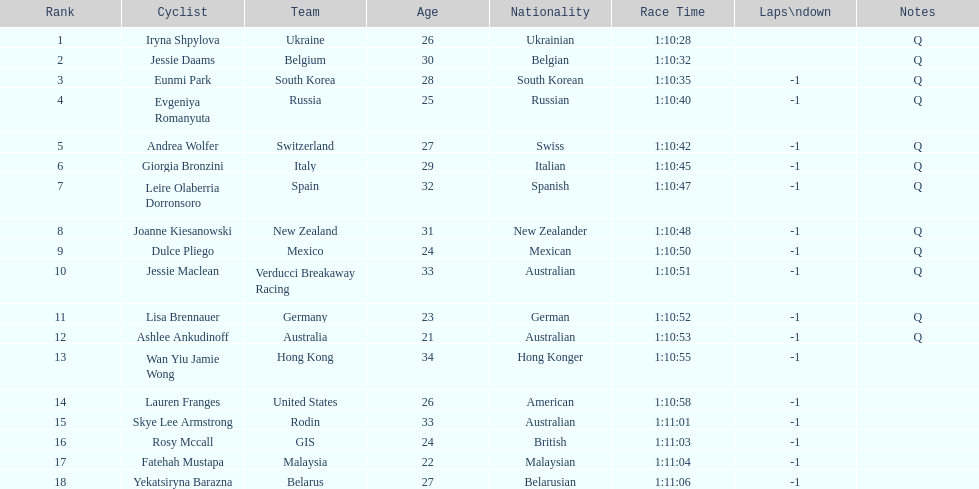What team is listed previous to belgium? Ukraine. 